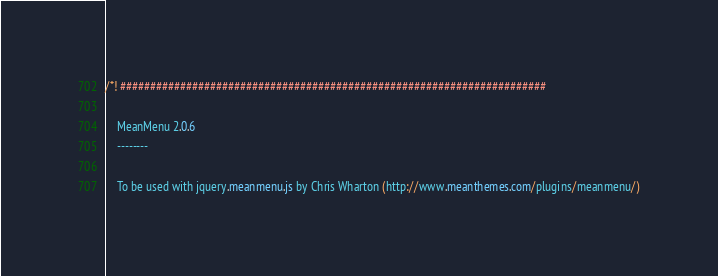<code> <loc_0><loc_0><loc_500><loc_500><_CSS_>/*! #######################################################################

	MeanMenu 2.0.6
	--------
	
	To be used with jquery.meanmenu.js by Chris Wharton (http://www.meanthemes.com/plugins/meanmenu/)
</code> 